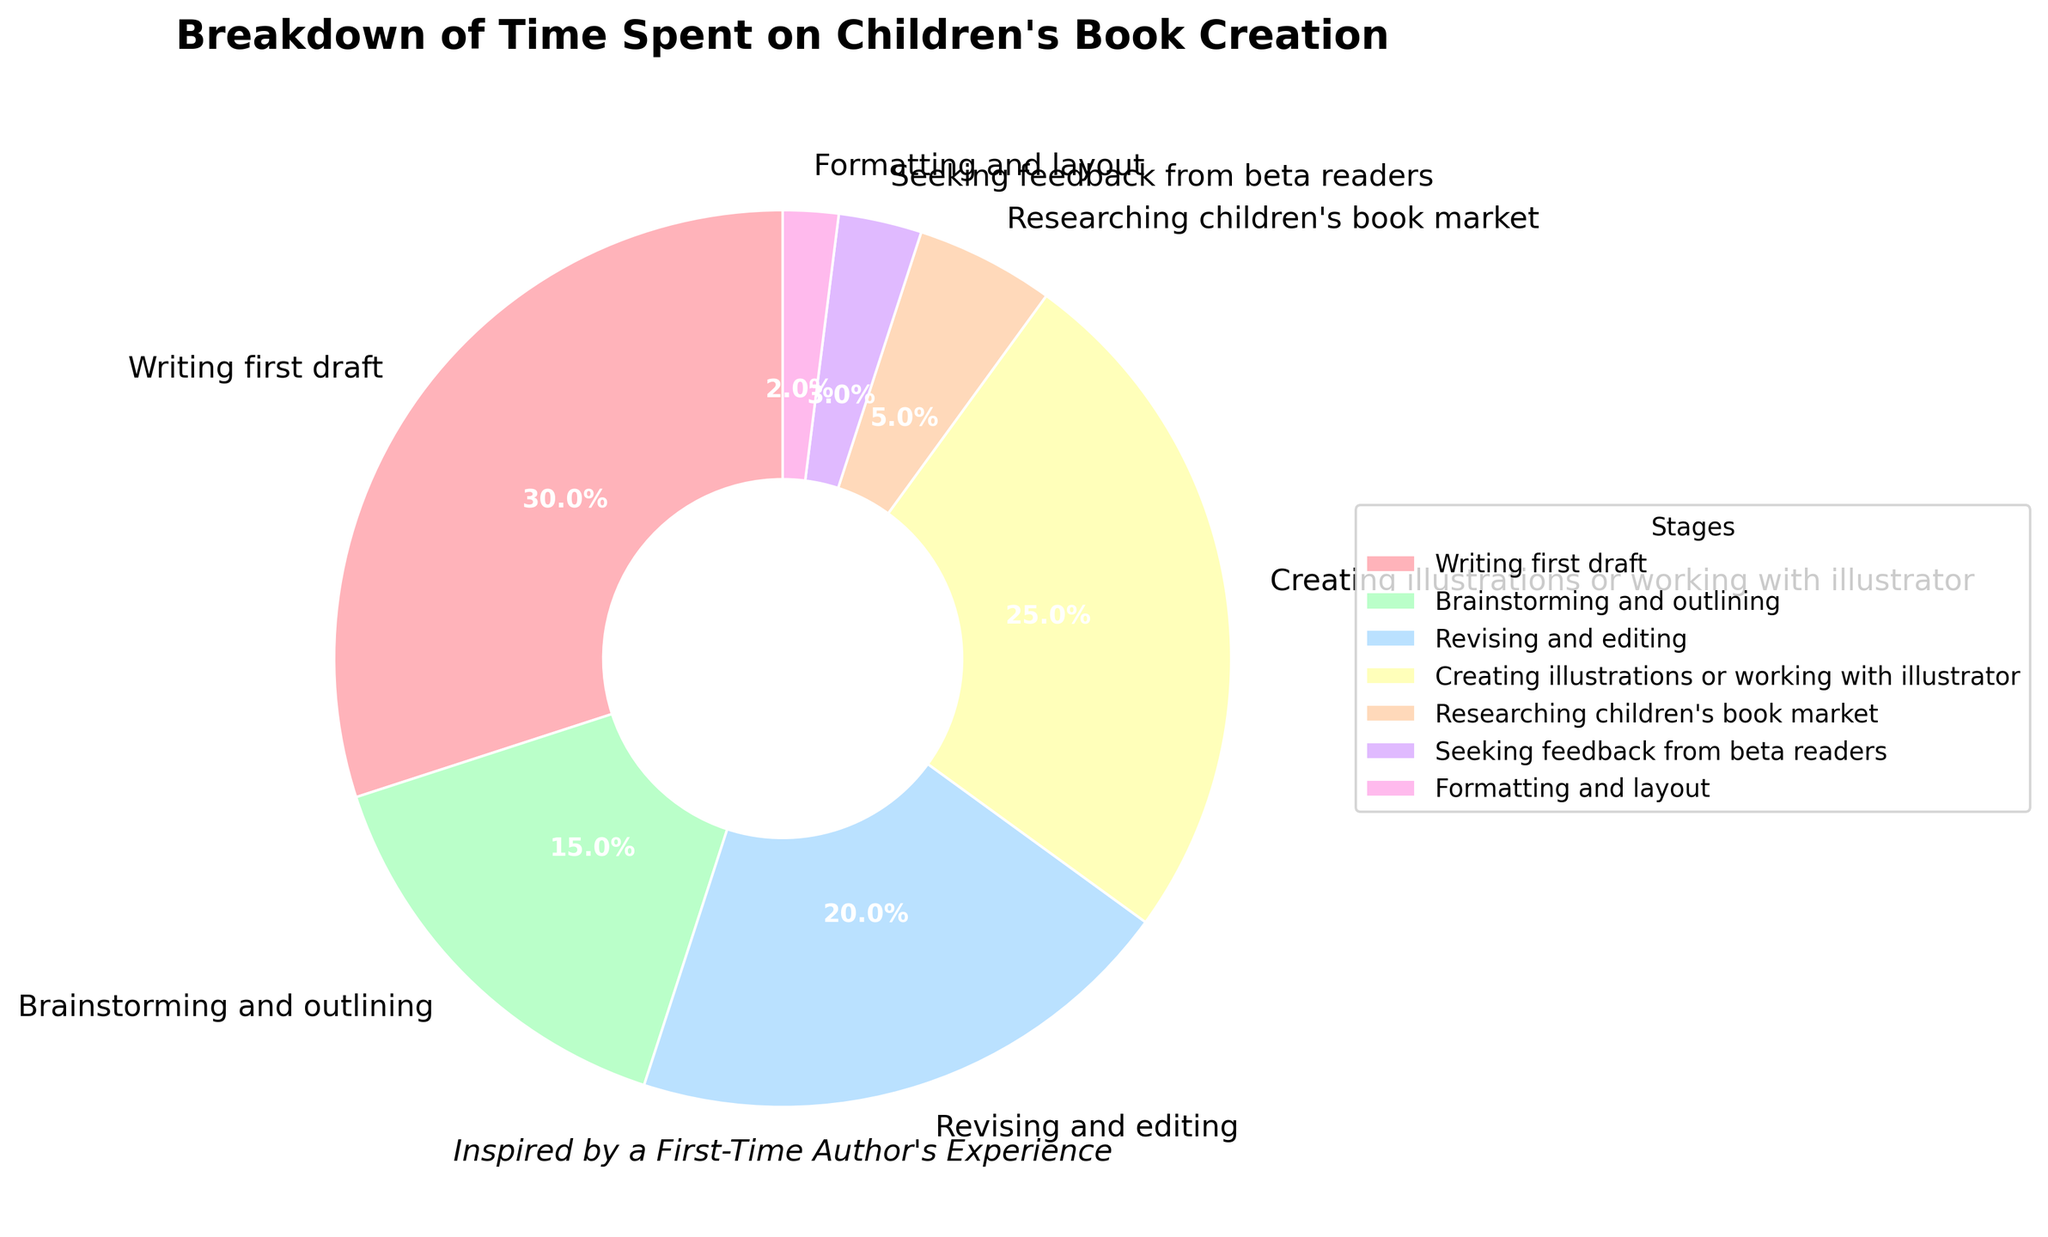What stage takes up the largest percentage of time in creating children's books? Look at the largest wedge in the pie chart, which represents 30% and is labeled "Writing first draft".
Answer: Writing first draft What stages together take up exactly half of the time spent creating the book? Identify stages that sum up to 50%. "Writing first draft" (30%) + "Creating illustrations or working with illustrator" (25%) = 55%, which exceeds half. Instead, "Writing first draft" (30%) + "Revising and editing" (20%) = 50%, so these two stages make up half.
Answer: Writing first draft and Revising and editing What is the total percentage of time spent on brainstorming and outlining, and revising and editing? Add the percentages for "Brainstorming and outlining" (15%) and "Revising and editing" (20%) together: 15% + 20% = 35%.
Answer: 35% How much more time is spent creating illustrations compared to researching the children's book market? Subtract the percentage of "Researching children's book market" (5%) from "Creating illustrations or working with illustrator" (25%): 25% - 5% = 20%.
Answer: 20% What stage takes up the least amount of time? Look for the smallest wedge in the pie chart, which represents 2% and is labeled "Formatting and layout".
Answer: Formatting and layout Which stages together account for more than 60% of the time spent? Identify stages whose summed percentages exceed 60%. "Writing first draft" (30%) + "Creating illustrations or working with illustrator" (25%) = 55%. Adding "Revising and editing" (20%) results in: 55% + 20% = 75%. Thus, these three stages take more than 60%.
Answer: Writing first draft, Creating illustrations, Revising and editing What is the difference in time spent between seeking feedback from beta readers and formatting and layout? Subtract the percentage of "Formatting and layout" (2%) from "Seeking feedback from beta readers" (3%): 3% - 2% = 1%.
Answer: 1% Which colored wedge represents the time spent on creating illustrations or working with an illustrator? Observe the visual attribute - the color of the wedge associated with "Creating illustrations or working with illustrator", which is purple.
Answer: Purple 